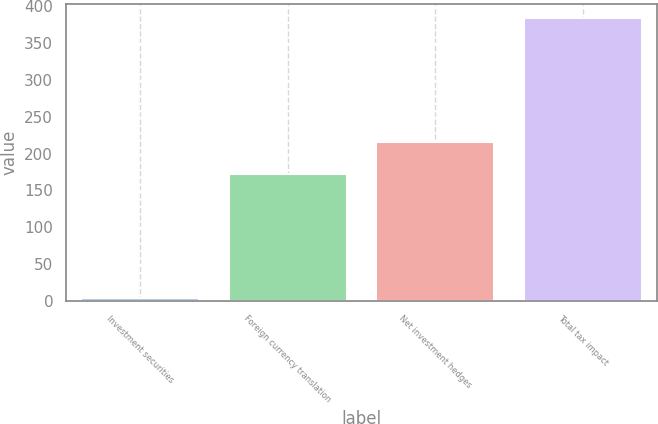<chart> <loc_0><loc_0><loc_500><loc_500><bar_chart><fcel>Investment securities<fcel>Foreign currency translation<fcel>Net investment hedges<fcel>Total tax impact<nl><fcel>4<fcel>172<fcel>215<fcel>384<nl></chart> 